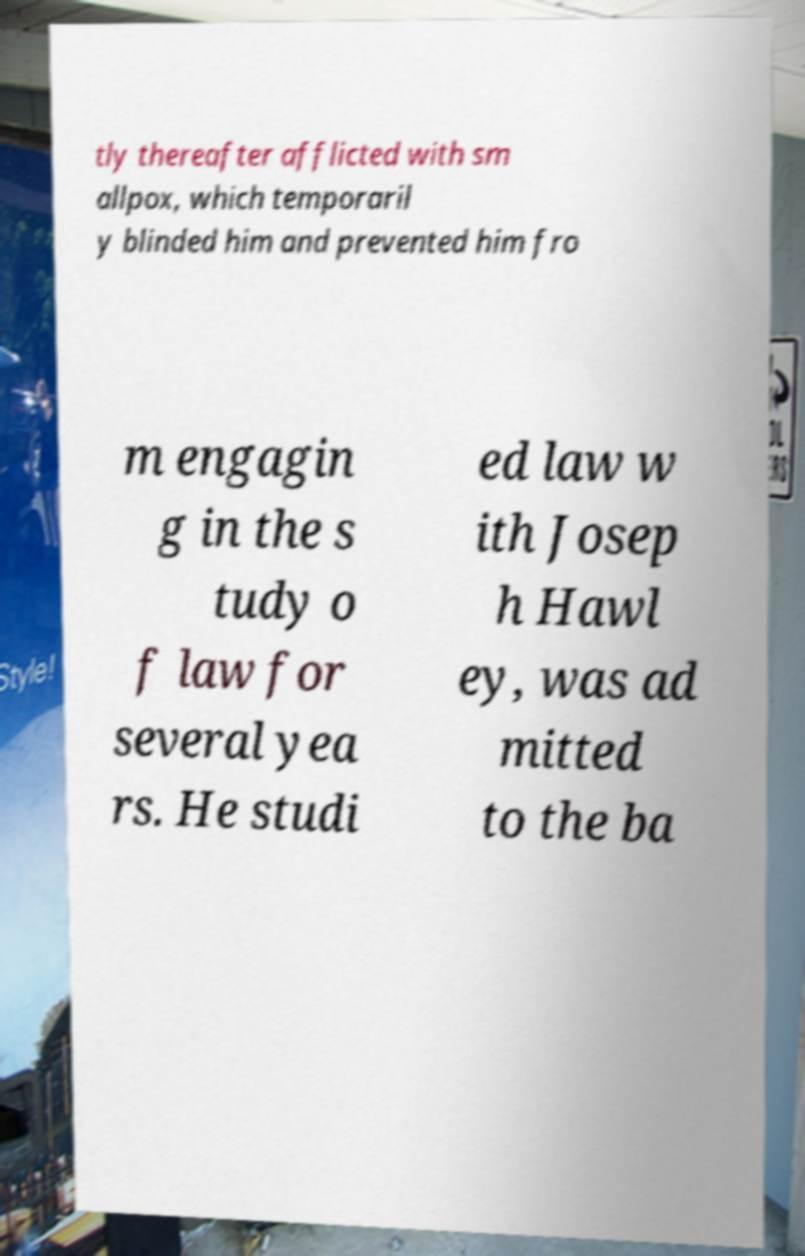Can you accurately transcribe the text from the provided image for me? tly thereafter afflicted with sm allpox, which temporaril y blinded him and prevented him fro m engagin g in the s tudy o f law for several yea rs. He studi ed law w ith Josep h Hawl ey, was ad mitted to the ba 